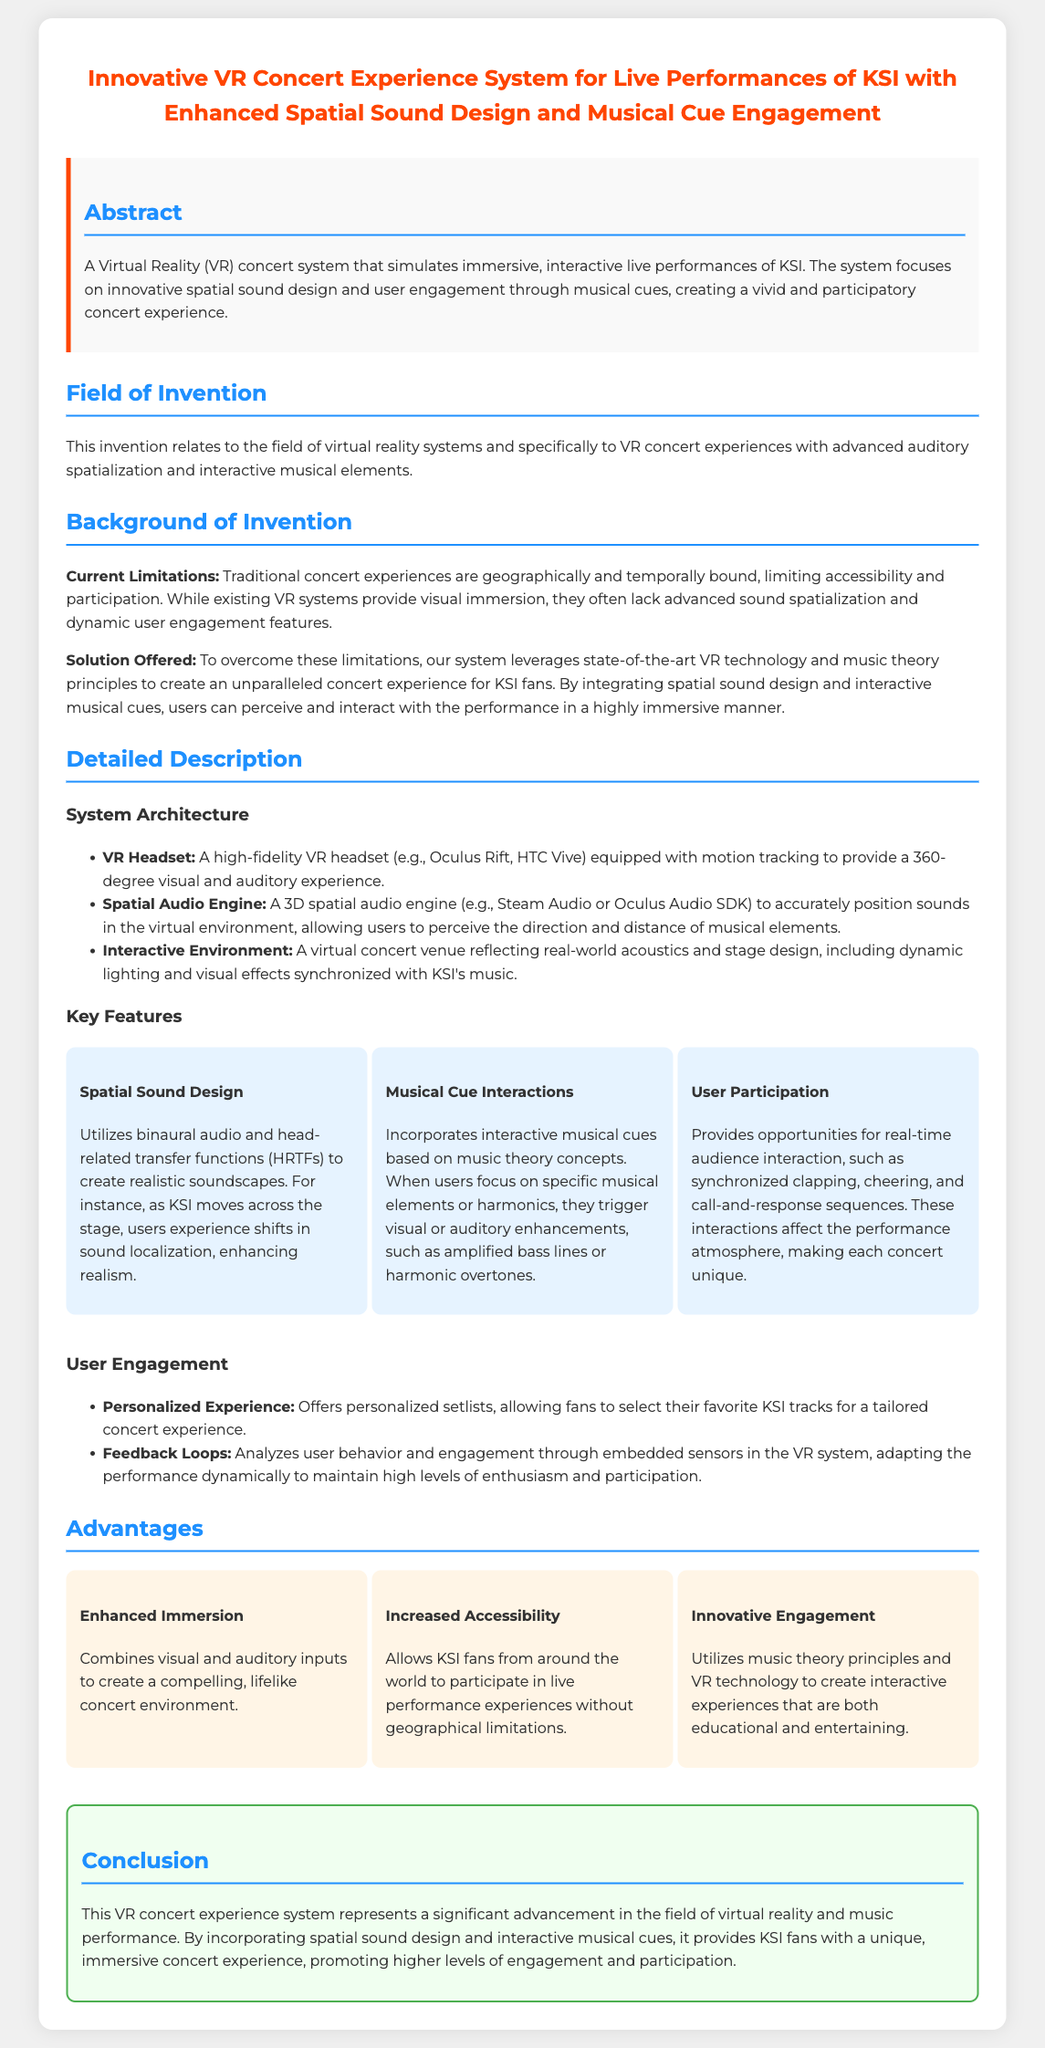what is the title of the patent application? The title is prominently displayed at the top of the document and describes the system for VR concerts.
Answer: Innovative VR Concert Experience System for Live Performances of KSI with Enhanced Spatial Sound Design and Musical Cue Engagement what technology does the system use for sound? The document mentions a specific component responsible for sound design, which indicates the technology used.
Answer: Spatial Audio Engine how does the system enhance user experience? The document outlines several features that contribute to a better user experience, including one specific focus.
Answer: User Participation what principle does the system utilize for musical cue interactions? The document refers to educational and foundational concepts in music that guide the interactive features.
Answer: Music Theory what feature allows KSI fans to select songs? The section on user engagement describes a particular feature that personalizes the concert.
Answer: Personalized Experience which technology is mentioned for VR headsets? The document lists certain high-fidelity VR headsets that are compatible with the system.
Answer: Oculus Rift, HTC Vive what is one of the main advantages of the system? The document lists several advantages in a dedicated section, highlighting a key benefit of the system.
Answer: Enhanced Immersion what type of environment is created in the VR system? The detailed description explains the nature of the virtual setting for the concert experience.
Answer: Interactive Environment what does the conclusion say about the VR concert experience system? The conclusion summarizes the overall significance and contribution of the system in a few key phrases.
Answer: Significant advancement in the field of virtual reality and music performance 